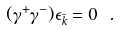<formula> <loc_0><loc_0><loc_500><loc_500>( \gamma ^ { + } \gamma ^ { - } ) \epsilon _ { \bar { k } } = 0 \ .</formula> 